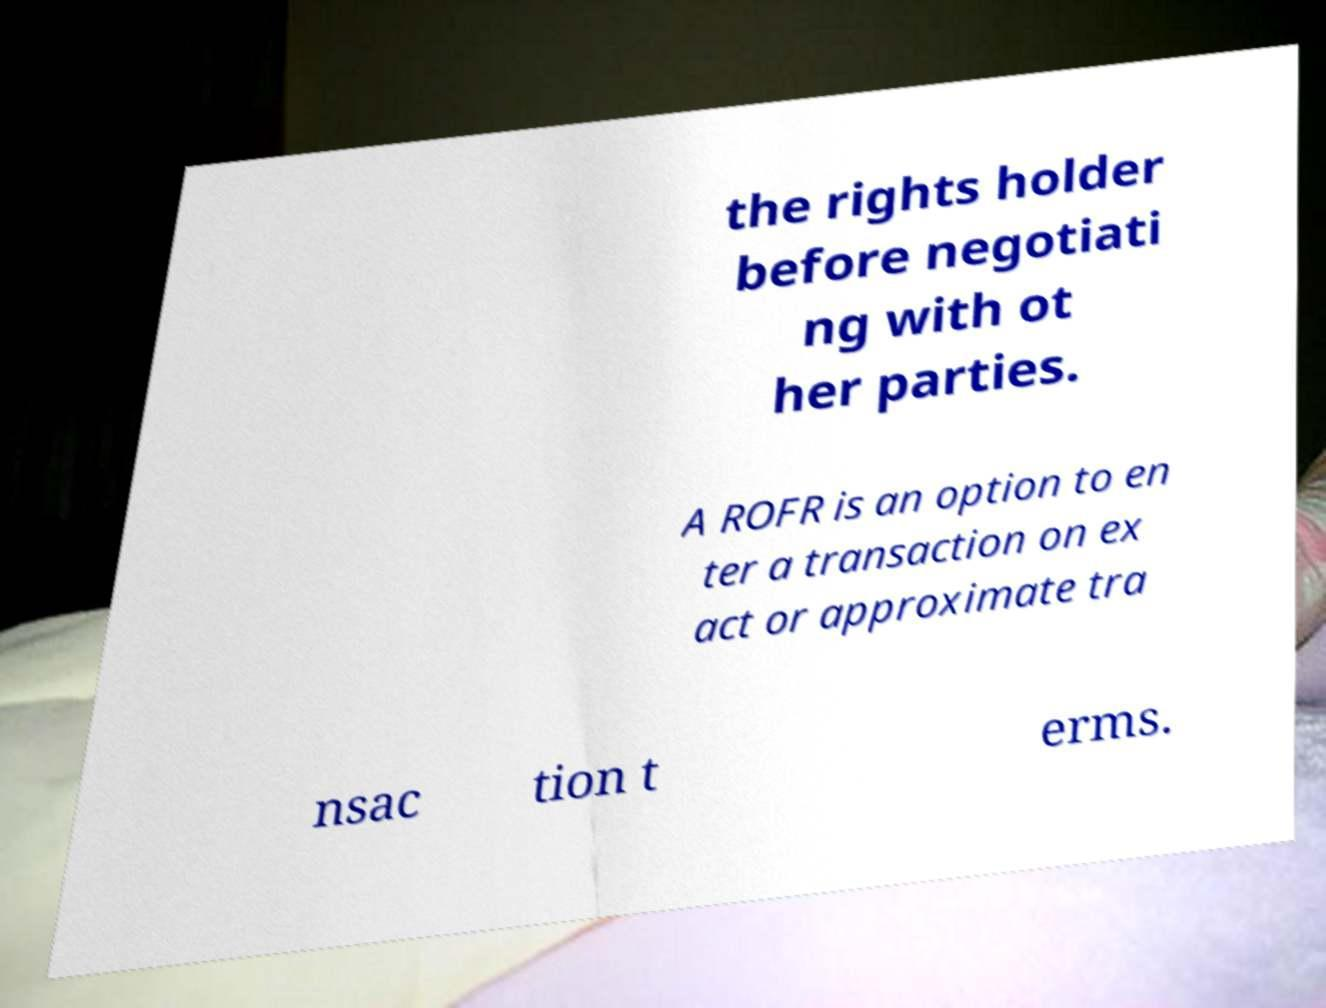Can you accurately transcribe the text from the provided image for me? the rights holder before negotiati ng with ot her parties. A ROFR is an option to en ter a transaction on ex act or approximate tra nsac tion t erms. 